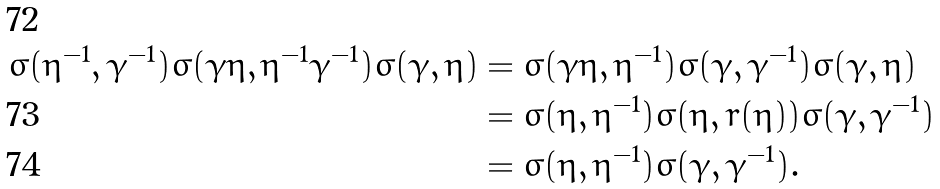<formula> <loc_0><loc_0><loc_500><loc_500>\sigma ( \eta ^ { - 1 } , \gamma ^ { - 1 } ) \sigma ( \gamma \eta , \eta ^ { - 1 } \gamma ^ { - 1 } ) \sigma ( \gamma , \eta ) & = \sigma ( \gamma \eta , \eta ^ { - 1 } ) \sigma ( \gamma , \gamma ^ { - 1 } ) \sigma ( \gamma , \eta ) \\ & = \sigma ( \eta , \eta ^ { - 1 } ) \sigma ( \eta , r ( \eta ) ) \sigma ( \gamma , \gamma ^ { - 1 } ) \\ & = \sigma ( \eta , \eta ^ { - 1 } ) \sigma ( \gamma , \gamma ^ { - 1 } ) .</formula> 